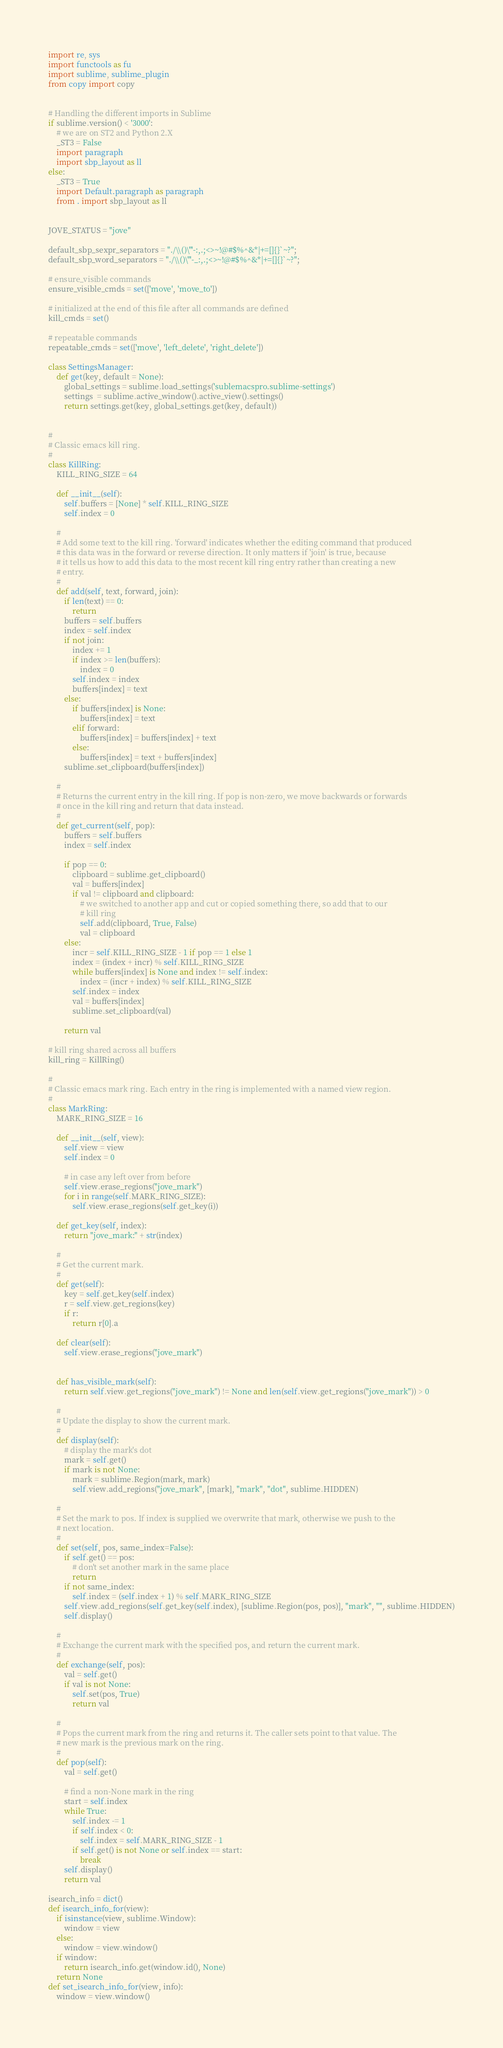<code> <loc_0><loc_0><loc_500><loc_500><_Python_>import re, sys
import functools as fu
import sublime, sublime_plugin
from copy import copy


# Handling the different imports in Sublime
if sublime.version() < '3000':
    # we are on ST2 and Python 2.X
    _ST3 = False
    import paragraph
    import sbp_layout as ll
else:
    _ST3 = True
    import Default.paragraph as paragraph
    from . import sbp_layout as ll


JOVE_STATUS = "jove"

default_sbp_sexpr_separators = "./\\()\"'-:,.;<>~!@#$%^&*|+=[]{}`~?";
default_sbp_word_separators = "./\\()\"'-_:,.;<>~!@#$%^&*|+=[]{}`~?";

# ensure_visible commands
ensure_visible_cmds = set(['move', 'move_to'])

# initialized at the end of this file after all commands are defined
kill_cmds = set()

# repeatable commands
repeatable_cmds = set(['move', 'left_delete', 'right_delete'])

class SettingsManager:
    def get(key, default = None):
        global_settings = sublime.load_settings('sublemacspro.sublime-settings')
        settings  = sublime.active_window().active_view().settings()
        return settings.get(key, global_settings.get(key, default))


#
# Classic emacs kill ring.
#
class KillRing:
    KILL_RING_SIZE = 64

    def __init__(self):
        self.buffers = [None] * self.KILL_RING_SIZE
        self.index = 0

    #
    # Add some text to the kill ring. 'forward' indicates whether the editing command that produced
    # this data was in the forward or reverse direction. It only matters if 'join' is true, because
    # it tells us how to add this data to the most recent kill ring entry rather than creating a new
    # entry.
    #
    def add(self, text, forward, join):
        if len(text) == 0:
            return
        buffers = self.buffers
        index = self.index
        if not join:
            index += 1
            if index >= len(buffers):
                index = 0
            self.index = index
            buffers[index] = text
        else:
            if buffers[index] is None:
                buffers[index] = text
            elif forward:
                buffers[index] = buffers[index] + text
            else:
                buffers[index] = text + buffers[index]
        sublime.set_clipboard(buffers[index])

    #
    # Returns the current entry in the kill ring. If pop is non-zero, we move backwards or forwards
    # once in the kill ring and return that data instead.
    #
    def get_current(self, pop):
        buffers = self.buffers
        index = self.index

        if pop == 0:
            clipboard = sublime.get_clipboard()
            val = buffers[index]
            if val != clipboard and clipboard:
                # we switched to another app and cut or copied something there, so add that to our
                # kill ring
                self.add(clipboard, True, False)
                val = clipboard
        else:
            incr = self.KILL_RING_SIZE - 1 if pop == 1 else 1
            index = (index + incr) % self.KILL_RING_SIZE
            while buffers[index] is None and index != self.index:
                index = (incr + index) % self.KILL_RING_SIZE
            self.index = index
            val = buffers[index]
            sublime.set_clipboard(val)

        return val

# kill ring shared across all buffers
kill_ring = KillRing()

#
# Classic emacs mark ring. Each entry in the ring is implemented with a named view region.
#
class MarkRing:
    MARK_RING_SIZE = 16

    def __init__(self, view):
        self.view = view
        self.index = 0

        # in case any left over from before
        self.view.erase_regions("jove_mark")
        for i in range(self.MARK_RING_SIZE):
            self.view.erase_regions(self.get_key(i))

    def get_key(self, index):
        return "jove_mark:" + str(index)

    #
    # Get the current mark.
    #
    def get(self):
        key = self.get_key(self.index)
        r = self.view.get_regions(key)
        if r:
            return r[0].a

    def clear(self):
        self.view.erase_regions("jove_mark")


    def has_visible_mark(self):
        return self.view.get_regions("jove_mark") != None and len(self.view.get_regions("jove_mark")) > 0

    #
    # Update the display to show the current mark.
    #
    def display(self):
        # display the mark's dot
        mark = self.get()
        if mark is not None:
            mark = sublime.Region(mark, mark)
            self.view.add_regions("jove_mark", [mark], "mark", "dot", sublime.HIDDEN)

    #
    # Set the mark to pos. If index is supplied we overwrite that mark, otherwise we push to the
    # next location.
    #
    def set(self, pos, same_index=False):
        if self.get() == pos:
            # don't set another mark in the same place
            return
        if not same_index:
            self.index = (self.index + 1) % self.MARK_RING_SIZE
        self.view.add_regions(self.get_key(self.index), [sublime.Region(pos, pos)], "mark", "", sublime.HIDDEN)
        self.display()

    #
    # Exchange the current mark with the specified pos, and return the current mark.
    #
    def exchange(self, pos):
        val = self.get()
        if val is not None:
            self.set(pos, True)
            return val

    #
    # Pops the current mark from the ring and returns it. The caller sets point to that value. The
    # new mark is the previous mark on the ring.
    #
    def pop(self):
        val = self.get()

        # find a non-None mark in the ring
        start = self.index
        while True:
            self.index -= 1
            if self.index < 0:
                self.index = self.MARK_RING_SIZE - 1
            if self.get() is not None or self.index == start:
                break
        self.display()
        return val

isearch_info = dict()
def isearch_info_for(view):
    if isinstance(view, sublime.Window):
        window = view
    else:
        window = view.window()
    if window:
        return isearch_info.get(window.id(), None)
    return None
def set_isearch_info_for(view, info):
    window = view.window()</code> 